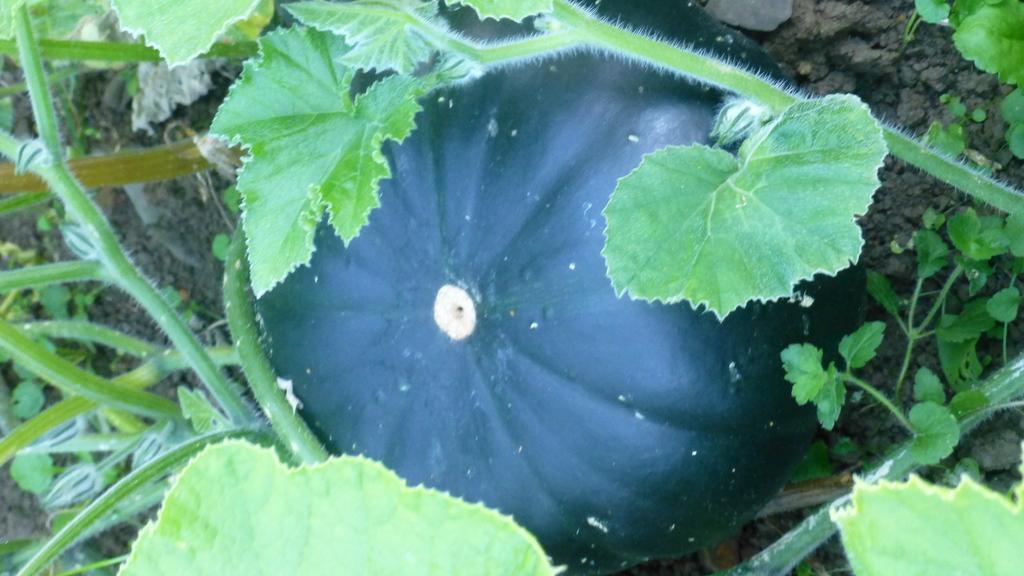How would you summarize this image in a sentence or two? In the center of the image we can see plants and pumpkin, which is in green color. 